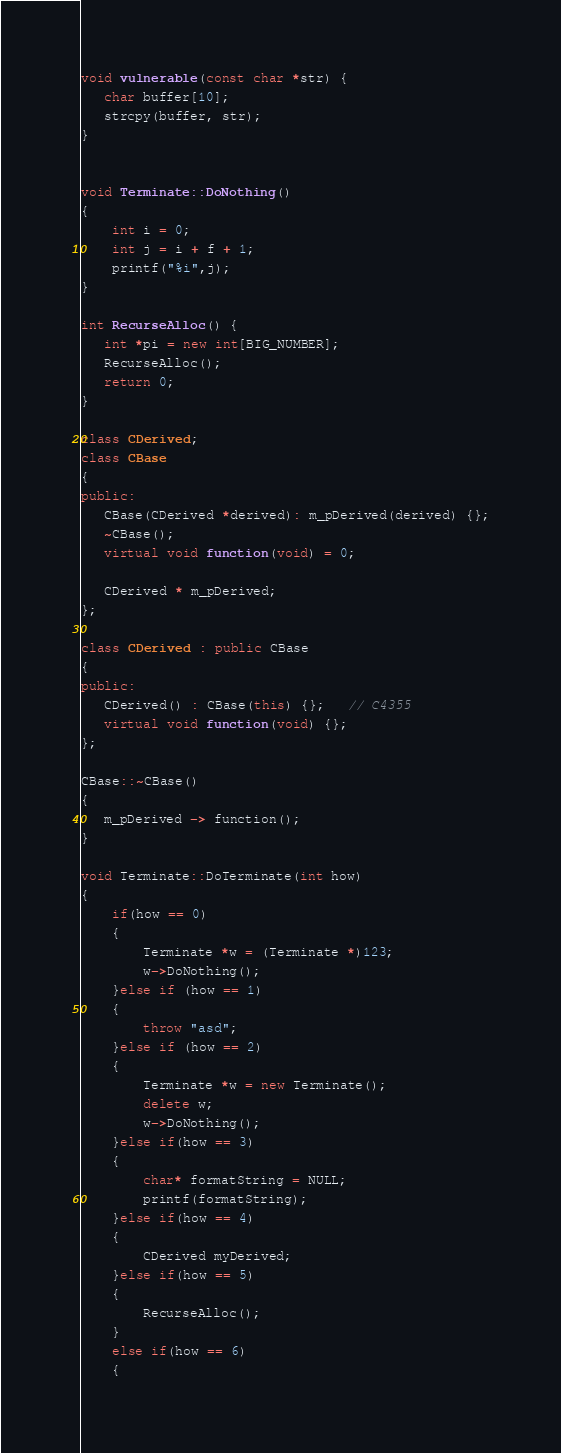Convert code to text. <code><loc_0><loc_0><loc_500><loc_500><_C++_>void vulnerable(const char *str) {
   char buffer[10];
   strcpy(buffer, str);
}


void Terminate::DoNothing()
{
    int i = 0;
    int j = i + f + 1;
    printf("%i",j);
}

int RecurseAlloc() {
   int *pi = new int[BIG_NUMBER];
   RecurseAlloc();
   return 0;
}

class CDerived;
class CBase
{
public:
   CBase(CDerived *derived): m_pDerived(derived) {};
   ~CBase();
   virtual void function(void) = 0;

   CDerived * m_pDerived;
};

class CDerived : public CBase
{
public:
   CDerived() : CBase(this) {};   // C4355
   virtual void function(void) {};
};

CBase::~CBase()
{
   m_pDerived -> function();
}

void Terminate::DoTerminate(int how)
{
    if(how == 0)
    {
        Terminate *w = (Terminate *)123;
        w->DoNothing();
    }else if (how == 1)
    {
        throw "asd";
    }else if (how == 2)
    {
        Terminate *w = new Terminate();
        delete w;
        w->DoNothing();
    }else if(how == 3)
    {
        char* formatString = NULL;
        printf(formatString);
    }else if(how == 4)
    {
        CDerived myDerived;
    }else if(how == 5)
    {
        RecurseAlloc();
    }
    else if(how == 6)
    {</code> 